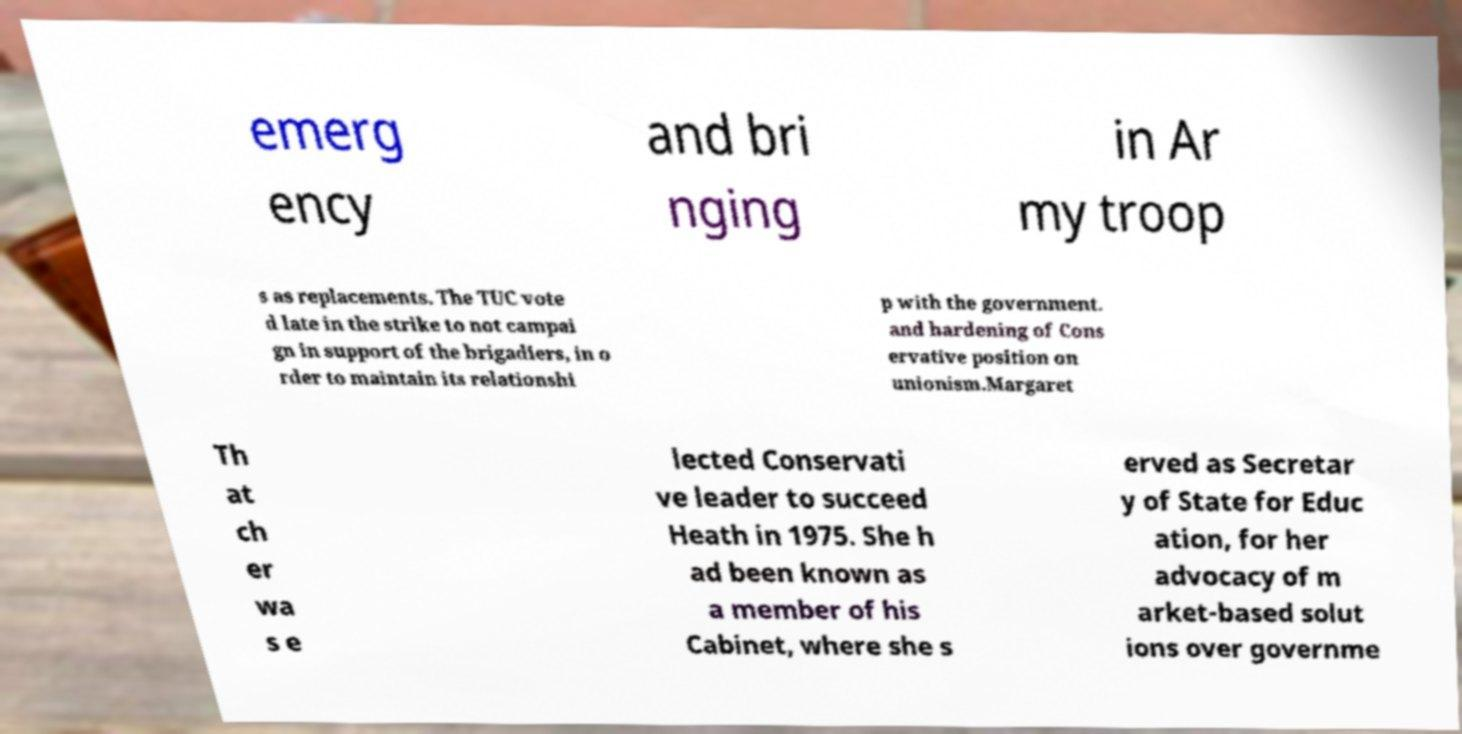Can you accurately transcribe the text from the provided image for me? emerg ency and bri nging in Ar my troop s as replacements. The TUC vote d late in the strike to not campai gn in support of the brigadiers, in o rder to maintain its relationshi p with the government. and hardening of Cons ervative position on unionism.Margaret Th at ch er wa s e lected Conservati ve leader to succeed Heath in 1975. She h ad been known as a member of his Cabinet, where she s erved as Secretar y of State for Educ ation, for her advocacy of m arket-based solut ions over governme 